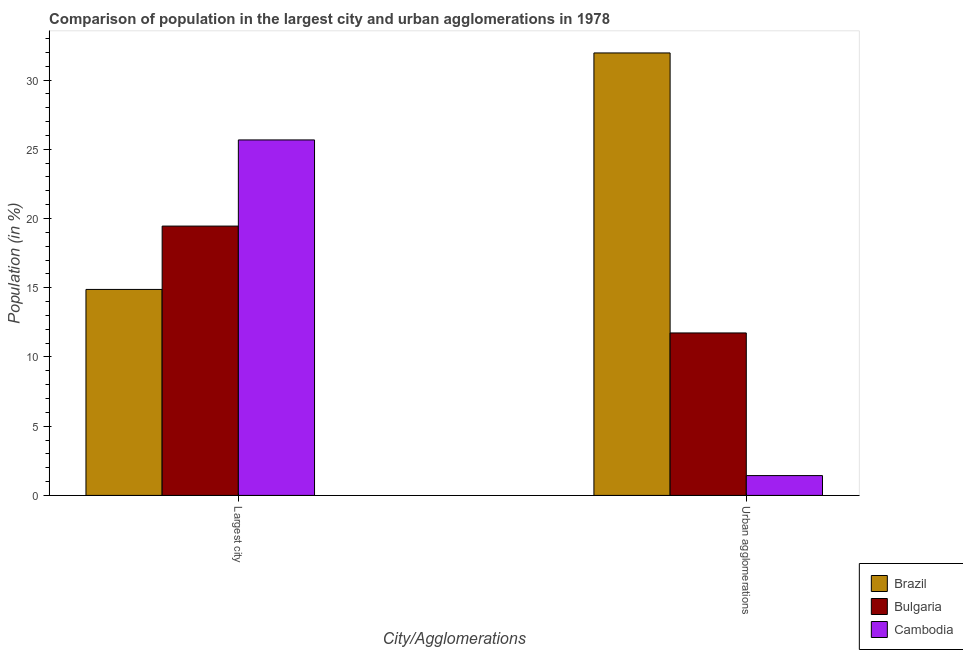How many groups of bars are there?
Make the answer very short. 2. Are the number of bars per tick equal to the number of legend labels?
Offer a terse response. Yes. Are the number of bars on each tick of the X-axis equal?
Your answer should be compact. Yes. How many bars are there on the 1st tick from the right?
Give a very brief answer. 3. What is the label of the 2nd group of bars from the left?
Your response must be concise. Urban agglomerations. What is the population in the largest city in Brazil?
Give a very brief answer. 14.88. Across all countries, what is the maximum population in the largest city?
Keep it short and to the point. 25.67. Across all countries, what is the minimum population in urban agglomerations?
Ensure brevity in your answer.  1.43. In which country was the population in urban agglomerations maximum?
Give a very brief answer. Brazil. What is the total population in urban agglomerations in the graph?
Offer a terse response. 45.12. What is the difference between the population in the largest city in Brazil and that in Bulgaria?
Keep it short and to the point. -4.58. What is the difference between the population in the largest city in Brazil and the population in urban agglomerations in Bulgaria?
Ensure brevity in your answer.  3.14. What is the average population in the largest city per country?
Ensure brevity in your answer.  20. What is the difference between the population in the largest city and population in urban agglomerations in Cambodia?
Make the answer very short. 24.24. In how many countries, is the population in the largest city greater than 19 %?
Provide a short and direct response. 2. What is the ratio of the population in the largest city in Brazil to that in Bulgaria?
Your answer should be compact. 0.76. Is the population in urban agglomerations in Bulgaria less than that in Brazil?
Your answer should be very brief. Yes. What does the 1st bar from the left in Largest city represents?
Your response must be concise. Brazil. How many bars are there?
Ensure brevity in your answer.  6. How many countries are there in the graph?
Your response must be concise. 3. What is the difference between two consecutive major ticks on the Y-axis?
Ensure brevity in your answer.  5. Are the values on the major ticks of Y-axis written in scientific E-notation?
Your response must be concise. No. Does the graph contain any zero values?
Make the answer very short. No. Does the graph contain grids?
Provide a succinct answer. No. How are the legend labels stacked?
Provide a short and direct response. Vertical. What is the title of the graph?
Provide a short and direct response. Comparison of population in the largest city and urban agglomerations in 1978. Does "South Sudan" appear as one of the legend labels in the graph?
Ensure brevity in your answer.  No. What is the label or title of the X-axis?
Provide a succinct answer. City/Agglomerations. What is the label or title of the Y-axis?
Your answer should be compact. Population (in %). What is the Population (in %) in Brazil in Largest city?
Provide a short and direct response. 14.88. What is the Population (in %) of Bulgaria in Largest city?
Provide a short and direct response. 19.45. What is the Population (in %) of Cambodia in Largest city?
Ensure brevity in your answer.  25.67. What is the Population (in %) in Brazil in Urban agglomerations?
Make the answer very short. 31.96. What is the Population (in %) in Bulgaria in Urban agglomerations?
Provide a short and direct response. 11.73. What is the Population (in %) of Cambodia in Urban agglomerations?
Keep it short and to the point. 1.43. Across all City/Agglomerations, what is the maximum Population (in %) in Brazil?
Offer a very short reply. 31.96. Across all City/Agglomerations, what is the maximum Population (in %) of Bulgaria?
Keep it short and to the point. 19.45. Across all City/Agglomerations, what is the maximum Population (in %) in Cambodia?
Offer a very short reply. 25.67. Across all City/Agglomerations, what is the minimum Population (in %) of Brazil?
Keep it short and to the point. 14.88. Across all City/Agglomerations, what is the minimum Population (in %) in Bulgaria?
Keep it short and to the point. 11.73. Across all City/Agglomerations, what is the minimum Population (in %) of Cambodia?
Your answer should be very brief. 1.43. What is the total Population (in %) in Brazil in the graph?
Give a very brief answer. 46.83. What is the total Population (in %) in Bulgaria in the graph?
Your response must be concise. 31.19. What is the total Population (in %) in Cambodia in the graph?
Make the answer very short. 27.11. What is the difference between the Population (in %) in Brazil in Largest city and that in Urban agglomerations?
Give a very brief answer. -17.08. What is the difference between the Population (in %) in Bulgaria in Largest city and that in Urban agglomerations?
Keep it short and to the point. 7.72. What is the difference between the Population (in %) of Cambodia in Largest city and that in Urban agglomerations?
Offer a terse response. 24.24. What is the difference between the Population (in %) of Brazil in Largest city and the Population (in %) of Bulgaria in Urban agglomerations?
Provide a succinct answer. 3.14. What is the difference between the Population (in %) in Brazil in Largest city and the Population (in %) in Cambodia in Urban agglomerations?
Make the answer very short. 13.44. What is the difference between the Population (in %) in Bulgaria in Largest city and the Population (in %) in Cambodia in Urban agglomerations?
Ensure brevity in your answer.  18.02. What is the average Population (in %) in Brazil per City/Agglomerations?
Provide a short and direct response. 23.42. What is the average Population (in %) in Bulgaria per City/Agglomerations?
Give a very brief answer. 15.59. What is the average Population (in %) of Cambodia per City/Agglomerations?
Ensure brevity in your answer.  13.55. What is the difference between the Population (in %) of Brazil and Population (in %) of Bulgaria in Largest city?
Offer a terse response. -4.58. What is the difference between the Population (in %) of Brazil and Population (in %) of Cambodia in Largest city?
Offer a very short reply. -10.8. What is the difference between the Population (in %) in Bulgaria and Population (in %) in Cambodia in Largest city?
Give a very brief answer. -6.22. What is the difference between the Population (in %) of Brazil and Population (in %) of Bulgaria in Urban agglomerations?
Your answer should be compact. 20.22. What is the difference between the Population (in %) of Brazil and Population (in %) of Cambodia in Urban agglomerations?
Make the answer very short. 30.52. What is the difference between the Population (in %) of Bulgaria and Population (in %) of Cambodia in Urban agglomerations?
Ensure brevity in your answer.  10.3. What is the ratio of the Population (in %) of Brazil in Largest city to that in Urban agglomerations?
Ensure brevity in your answer.  0.47. What is the ratio of the Population (in %) in Bulgaria in Largest city to that in Urban agglomerations?
Keep it short and to the point. 1.66. What is the ratio of the Population (in %) of Cambodia in Largest city to that in Urban agglomerations?
Ensure brevity in your answer.  17.93. What is the difference between the highest and the second highest Population (in %) in Brazil?
Keep it short and to the point. 17.08. What is the difference between the highest and the second highest Population (in %) of Bulgaria?
Offer a terse response. 7.72. What is the difference between the highest and the second highest Population (in %) in Cambodia?
Provide a short and direct response. 24.24. What is the difference between the highest and the lowest Population (in %) of Brazil?
Offer a very short reply. 17.08. What is the difference between the highest and the lowest Population (in %) of Bulgaria?
Keep it short and to the point. 7.72. What is the difference between the highest and the lowest Population (in %) in Cambodia?
Your answer should be compact. 24.24. 